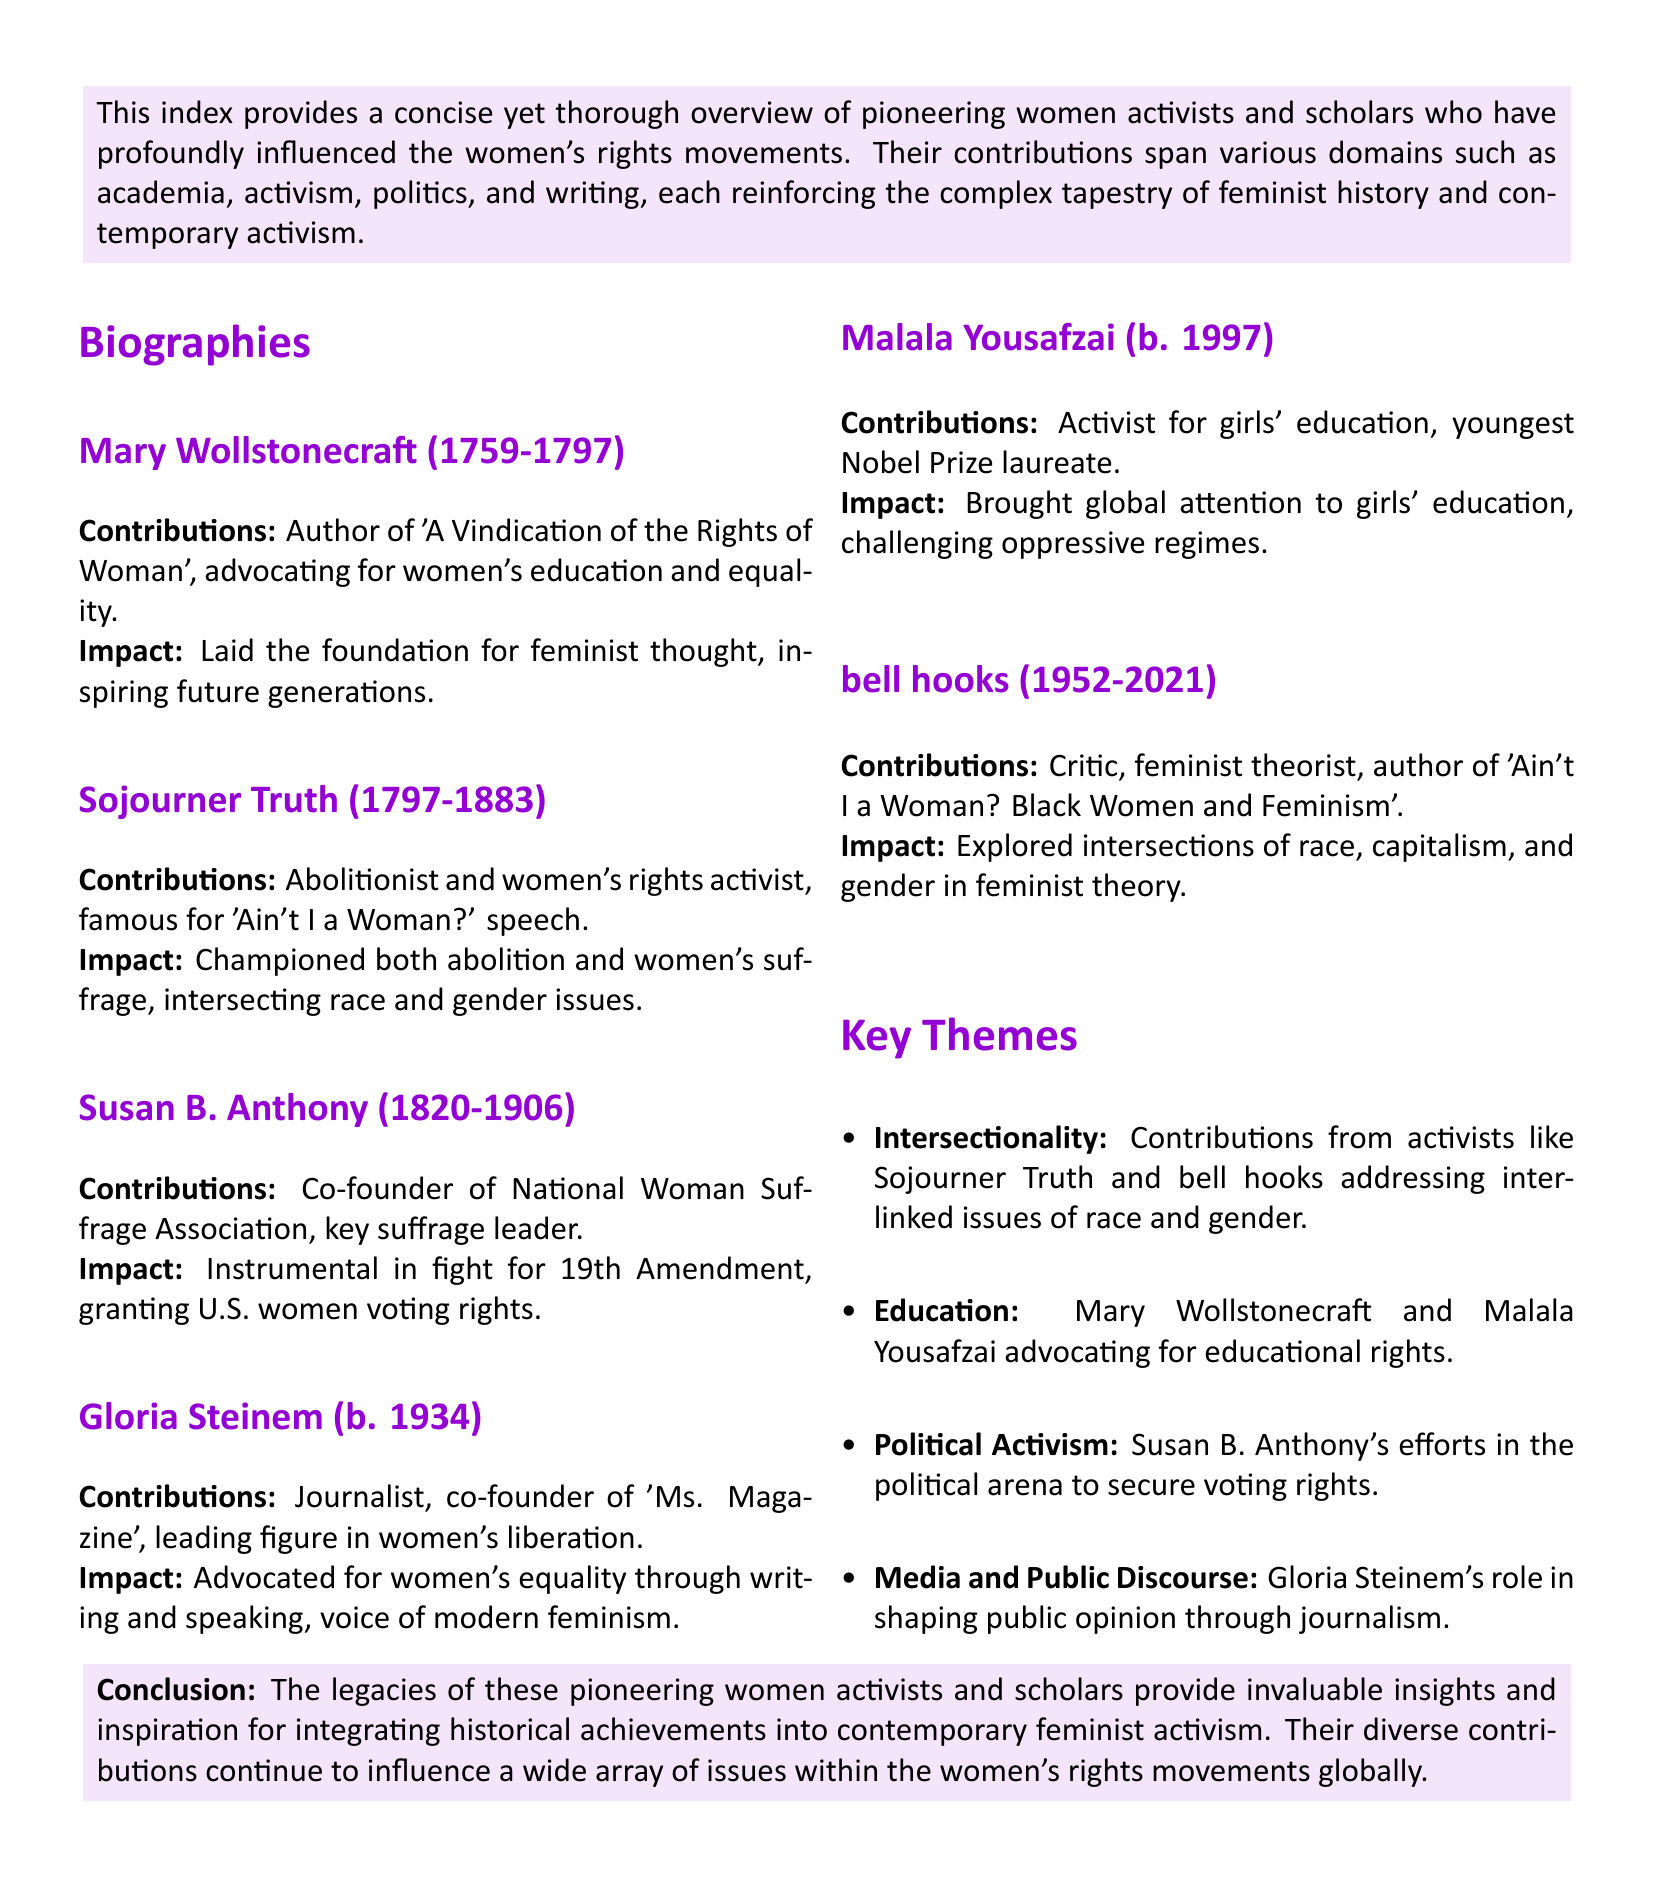What year was Mary Wollstonecraft born? The document states that Mary Wollstonecraft was born in 1759.
Answer: 1759 Who wrote 'Ain't I a Woman?' Sojourner Truth is credited with the speech 'Ain't I a Woman?'.
Answer: Sojourner Truth What organization did Susan B. Anthony co-found? The document mentions that she was a co-founder of the National Woman Suffrage Association.
Answer: National Woman Suffrage Association What is Gloria Steinem known for? She is known as a leading figure in women's liberation and a co-founder of 'Ms. Magazine'.
Answer: Women's liberation How old was Malala Yousafzai when she became a Nobel Prize laureate? The document states she is the youngest Nobel Prize laureate, having been born in 1997 and awarded in 2014.
Answer: 17 Which concept is explored by bell hooks in her work? The document highlights her exploration of intersections of race, capitalism, and gender in feminist theory.
Answer: Intersectionality What is a key theme related to Mary Wollstonecraft and Malala Yousafzai? The key theme connecting both activists is the advocacy for education rights.
Answer: Education How many biographies are listed in the document? The document lists five biographies of women activists and scholars.
Answer: Five What impact did Sojourner Truth have on the women's suffrage movement? She championed both abolition and women's suffrage, addressing race and gender issues.
Answer: Intersection of race and gender issues 